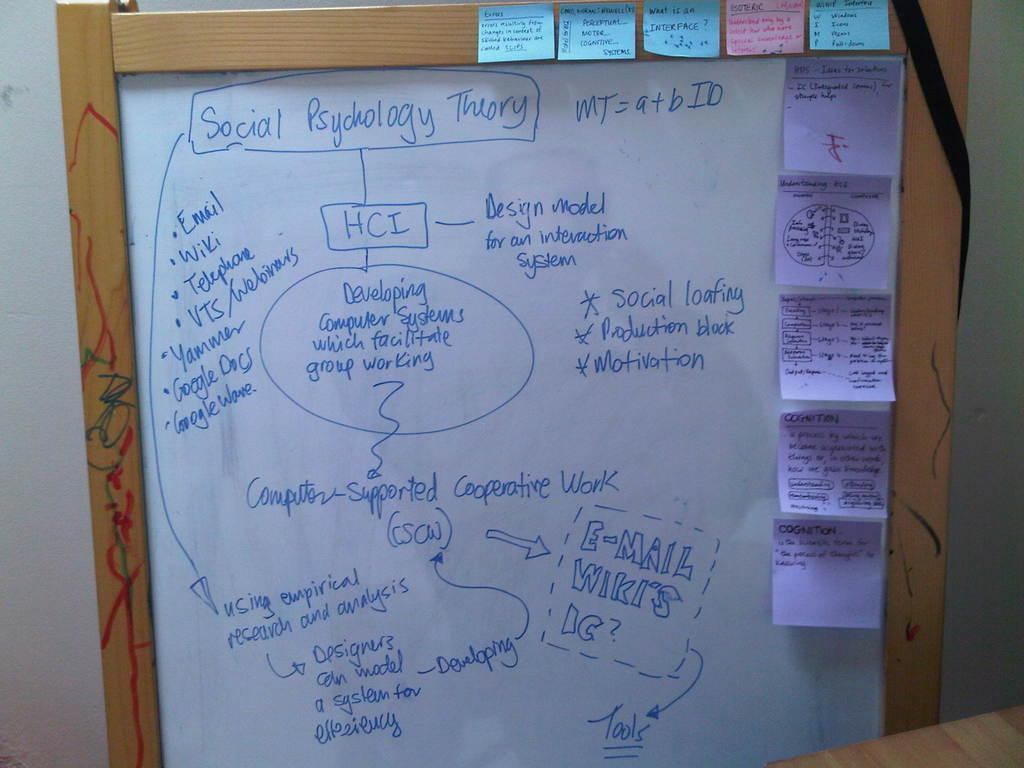What is the main object in the image? There is a board in the image. What is on the board? There is writing on the board and papers pasted on it. What type of fruit is hanging from the board in the image? There is no fruit hanging from the board in the image. What shape is the circle on the board in the image? There is no circle present on the board in the image. 